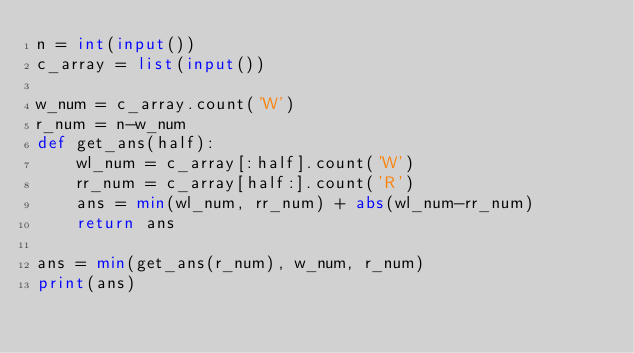<code> <loc_0><loc_0><loc_500><loc_500><_Python_>n = int(input())
c_array = list(input())

w_num = c_array.count('W')
r_num = n-w_num
def get_ans(half):
    wl_num = c_array[:half].count('W')
    rr_num = c_array[half:].count('R')
    ans = min(wl_num, rr_num) + abs(wl_num-rr_num)
    return ans

ans = min(get_ans(r_num), w_num, r_num)
print(ans)</code> 